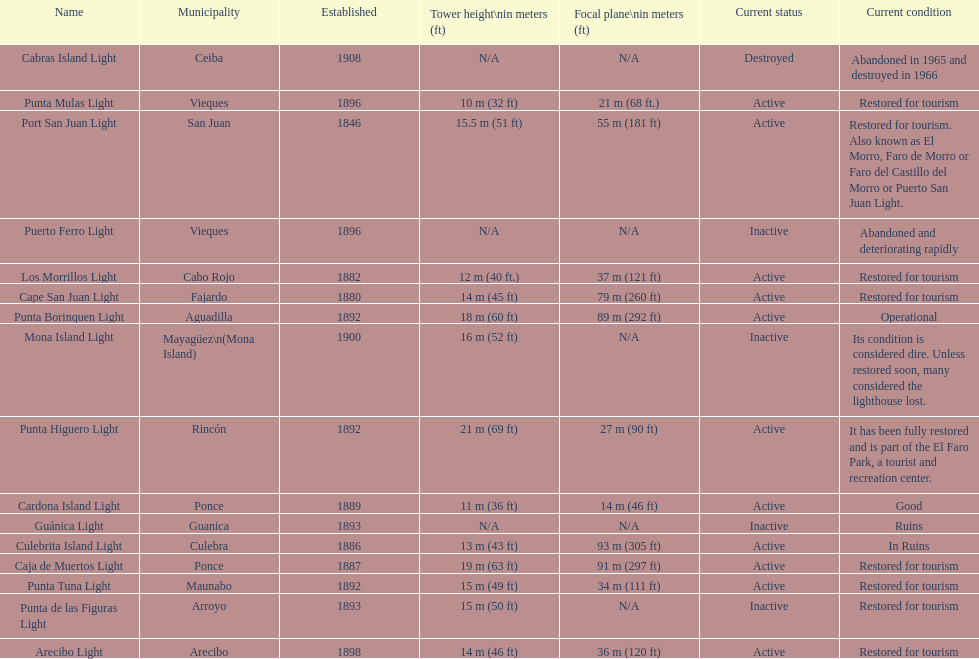Number of lighthouses that begin with the letter p 7. 